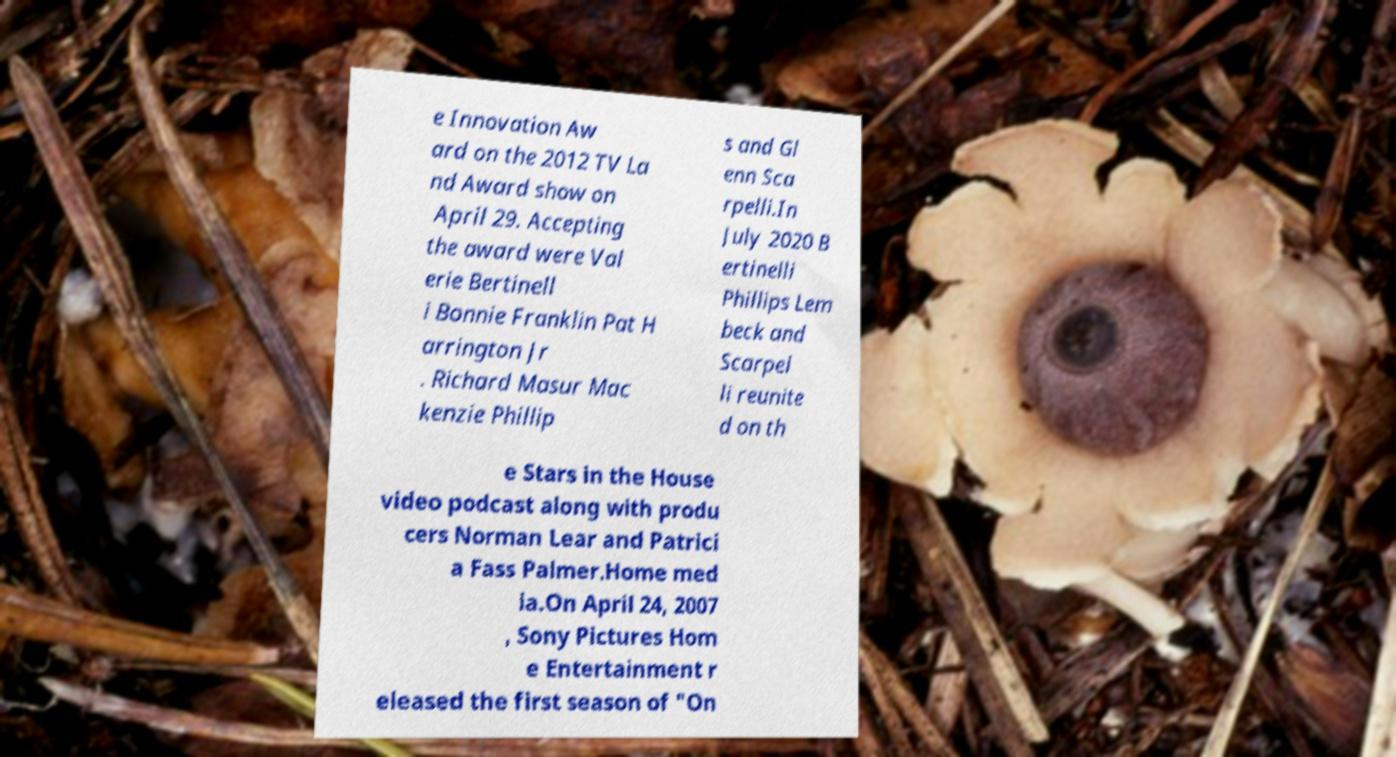There's text embedded in this image that I need extracted. Can you transcribe it verbatim? e Innovation Aw ard on the 2012 TV La nd Award show on April 29. Accepting the award were Val erie Bertinell i Bonnie Franklin Pat H arrington Jr . Richard Masur Mac kenzie Phillip s and Gl enn Sca rpelli.In July 2020 B ertinelli Phillips Lem beck and Scarpel li reunite d on th e Stars in the House video podcast along with produ cers Norman Lear and Patrici a Fass Palmer.Home med ia.On April 24, 2007 , Sony Pictures Hom e Entertainment r eleased the first season of "On 